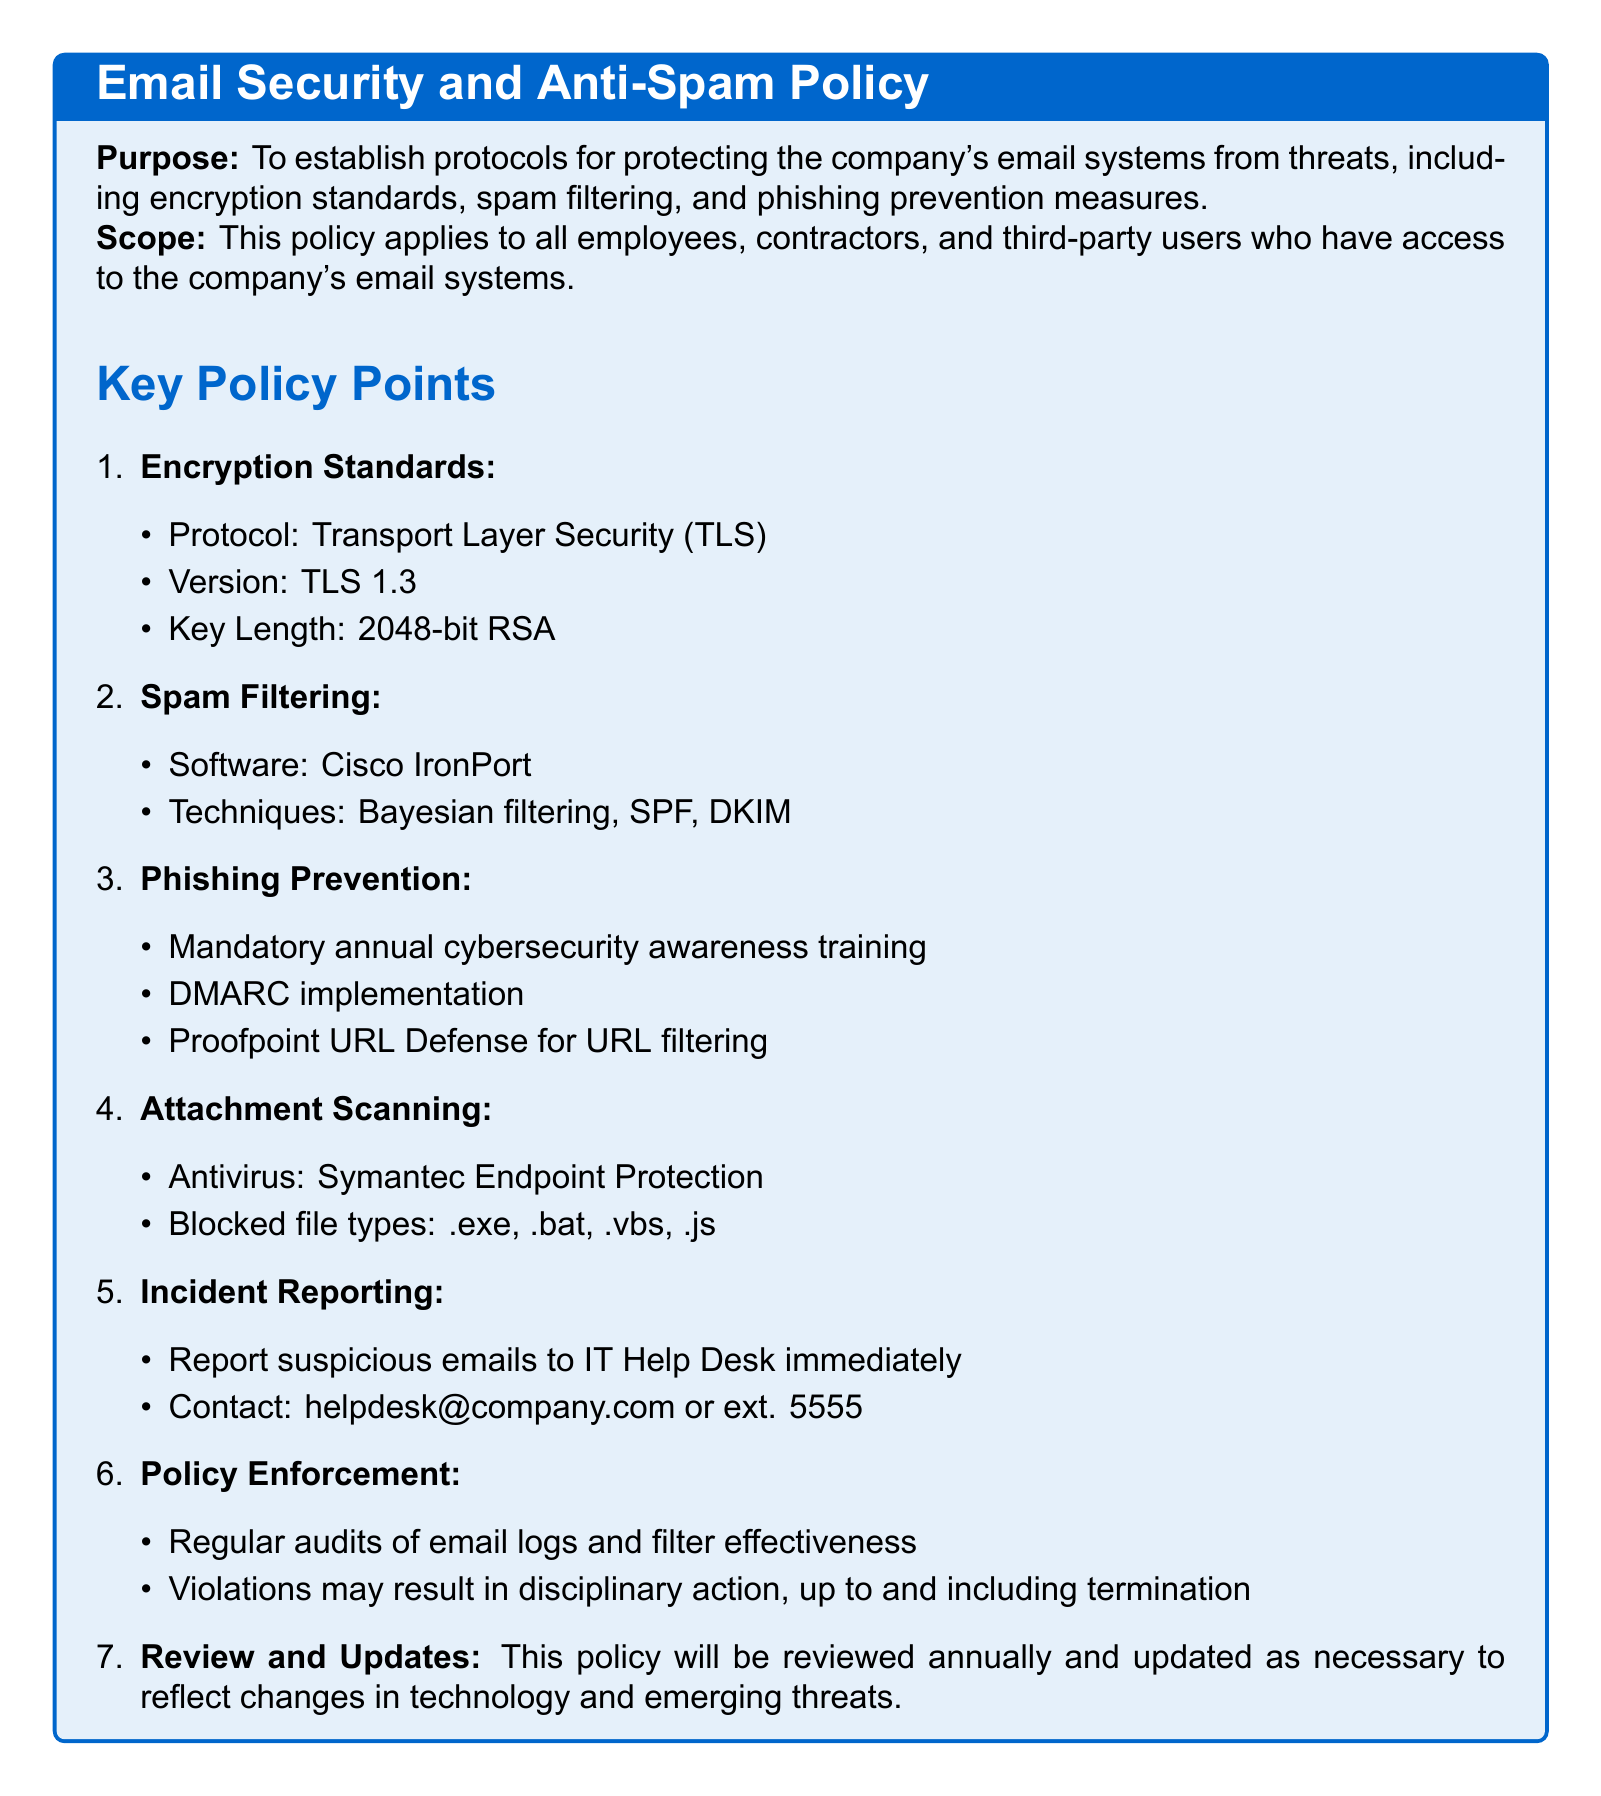What is the encryption protocol used? The encryption protocol specified in the policy document is Transport Layer Security (TLS).
Answer: Transport Layer Security (TLS) What is the key length for encryption? The document states that the key length is 2048-bit RSA.
Answer: 2048-bit RSA What software is used for spam filtering? The policy mentions Cisco IronPort as the software for spam filtering.
Answer: Cisco IronPort What is the mandatory training for phishing prevention? The document requires annual cybersecurity awareness training for phishing prevention.
Answer: Annual cybersecurity awareness training What antivirus is used for attachment scanning? The policy specifies Symantec Endpoint Protection as the antivirus for attachment scanning.
Answer: Symantec Endpoint Protection How often will the policy be reviewed? According to the document, the policy will be reviewed annually.
Answer: Annually What action can result from policy violations? The document states that violations may result in disciplinary action, up to and including termination.
Answer: Termination What technique is included in spam filtering? The policy includes Bayesian filtering as one of the spam filtering techniques.
Answer: Bayesian filtering 